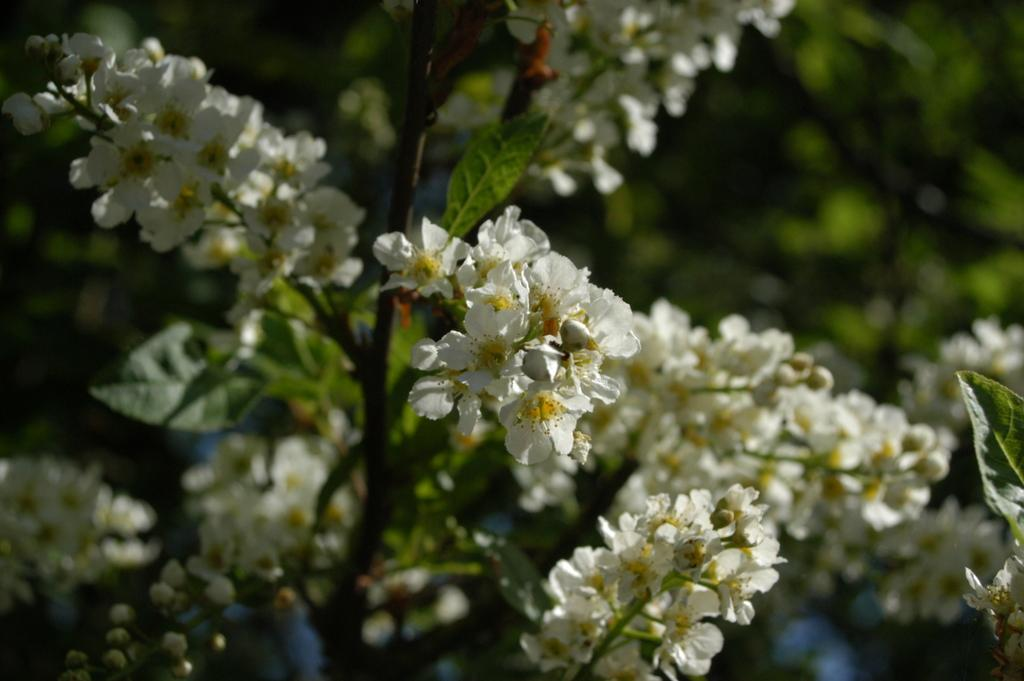What colors are the flowers in the image? The flowers in the image are white and yellow. What are the flowers growing on? The flowers are on plants. Can you describe the background of the image? The background of the image is blurred. How many jellyfish can be seen swimming in the image? There are no jellyfish present in the image; it features flowers on plants. What type of crib is visible in the image? There is no crib present in the image. 